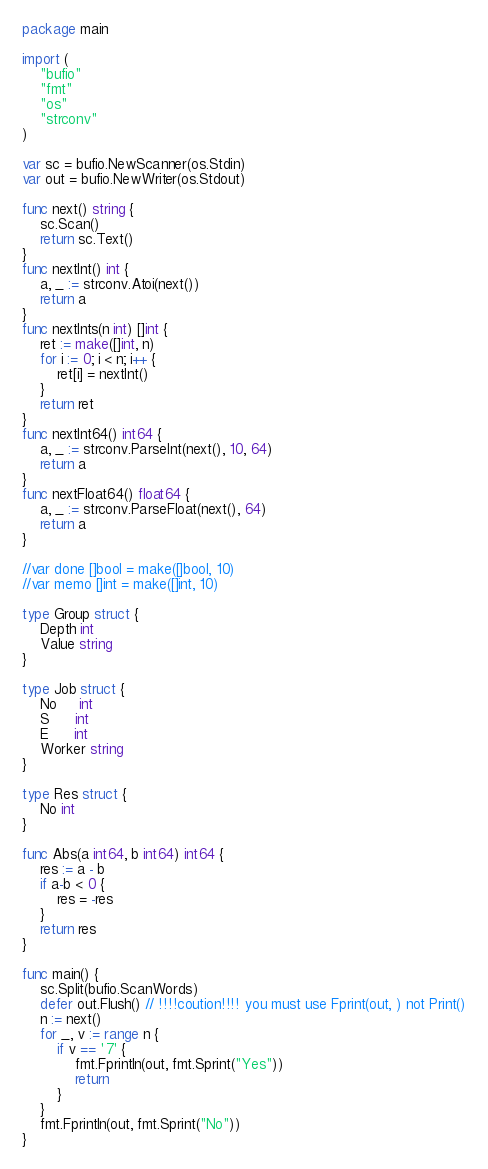Convert code to text. <code><loc_0><loc_0><loc_500><loc_500><_Go_>package main

import (
	"bufio"
	"fmt"
	"os"
	"strconv"
)

var sc = bufio.NewScanner(os.Stdin)
var out = bufio.NewWriter(os.Stdout)

func next() string {
	sc.Scan()
	return sc.Text()
}
func nextInt() int {
	a, _ := strconv.Atoi(next())
	return a
}
func nextInts(n int) []int {
	ret := make([]int, n)
	for i := 0; i < n; i++ {
		ret[i] = nextInt()
	}
	return ret
}
func nextInt64() int64 {
	a, _ := strconv.ParseInt(next(), 10, 64)
	return a
}
func nextFloat64() float64 {
	a, _ := strconv.ParseFloat(next(), 64)
	return a
}

//var done []bool = make([]bool, 10)
//var memo []int = make([]int, 10)

type Group struct {
	Depth int
	Value string
}

type Job struct {
	No     int
	S      int
	E      int
	Worker string
}

type Res struct {
	No int
}

func Abs(a int64, b int64) int64 {
	res := a - b
	if a-b < 0 {
		res = -res
	}
	return res
}

func main() {
	sc.Split(bufio.ScanWords)
	defer out.Flush() // !!!!coution!!!! you must use Fprint(out, ) not Print()
	n := next()
	for _, v := range n {
		if v == '7' {
			fmt.Fprintln(out, fmt.Sprint("Yes"))
			return
		}
	}
	fmt.Fprintln(out, fmt.Sprint("No"))
}
</code> 